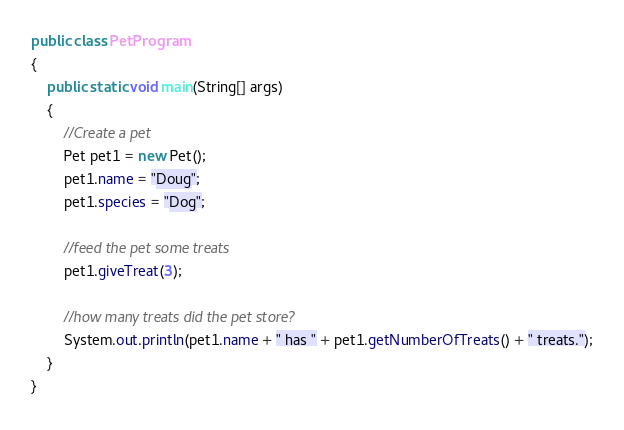Convert code to text. <code><loc_0><loc_0><loc_500><loc_500><_Java_>public class PetProgram
{
	public static void main(String[] args)
	{
		//Create a pet
		Pet pet1 = new Pet();
		pet1.name = "Doug";
		pet1.species = "Dog";

		//feed the pet some treats
		pet1.giveTreat(3);

		//how many treats did the pet store?
		System.out.println(pet1.name + " has " + pet1.getNumberOfTreats() + " treats.");
	}
}
</code> 